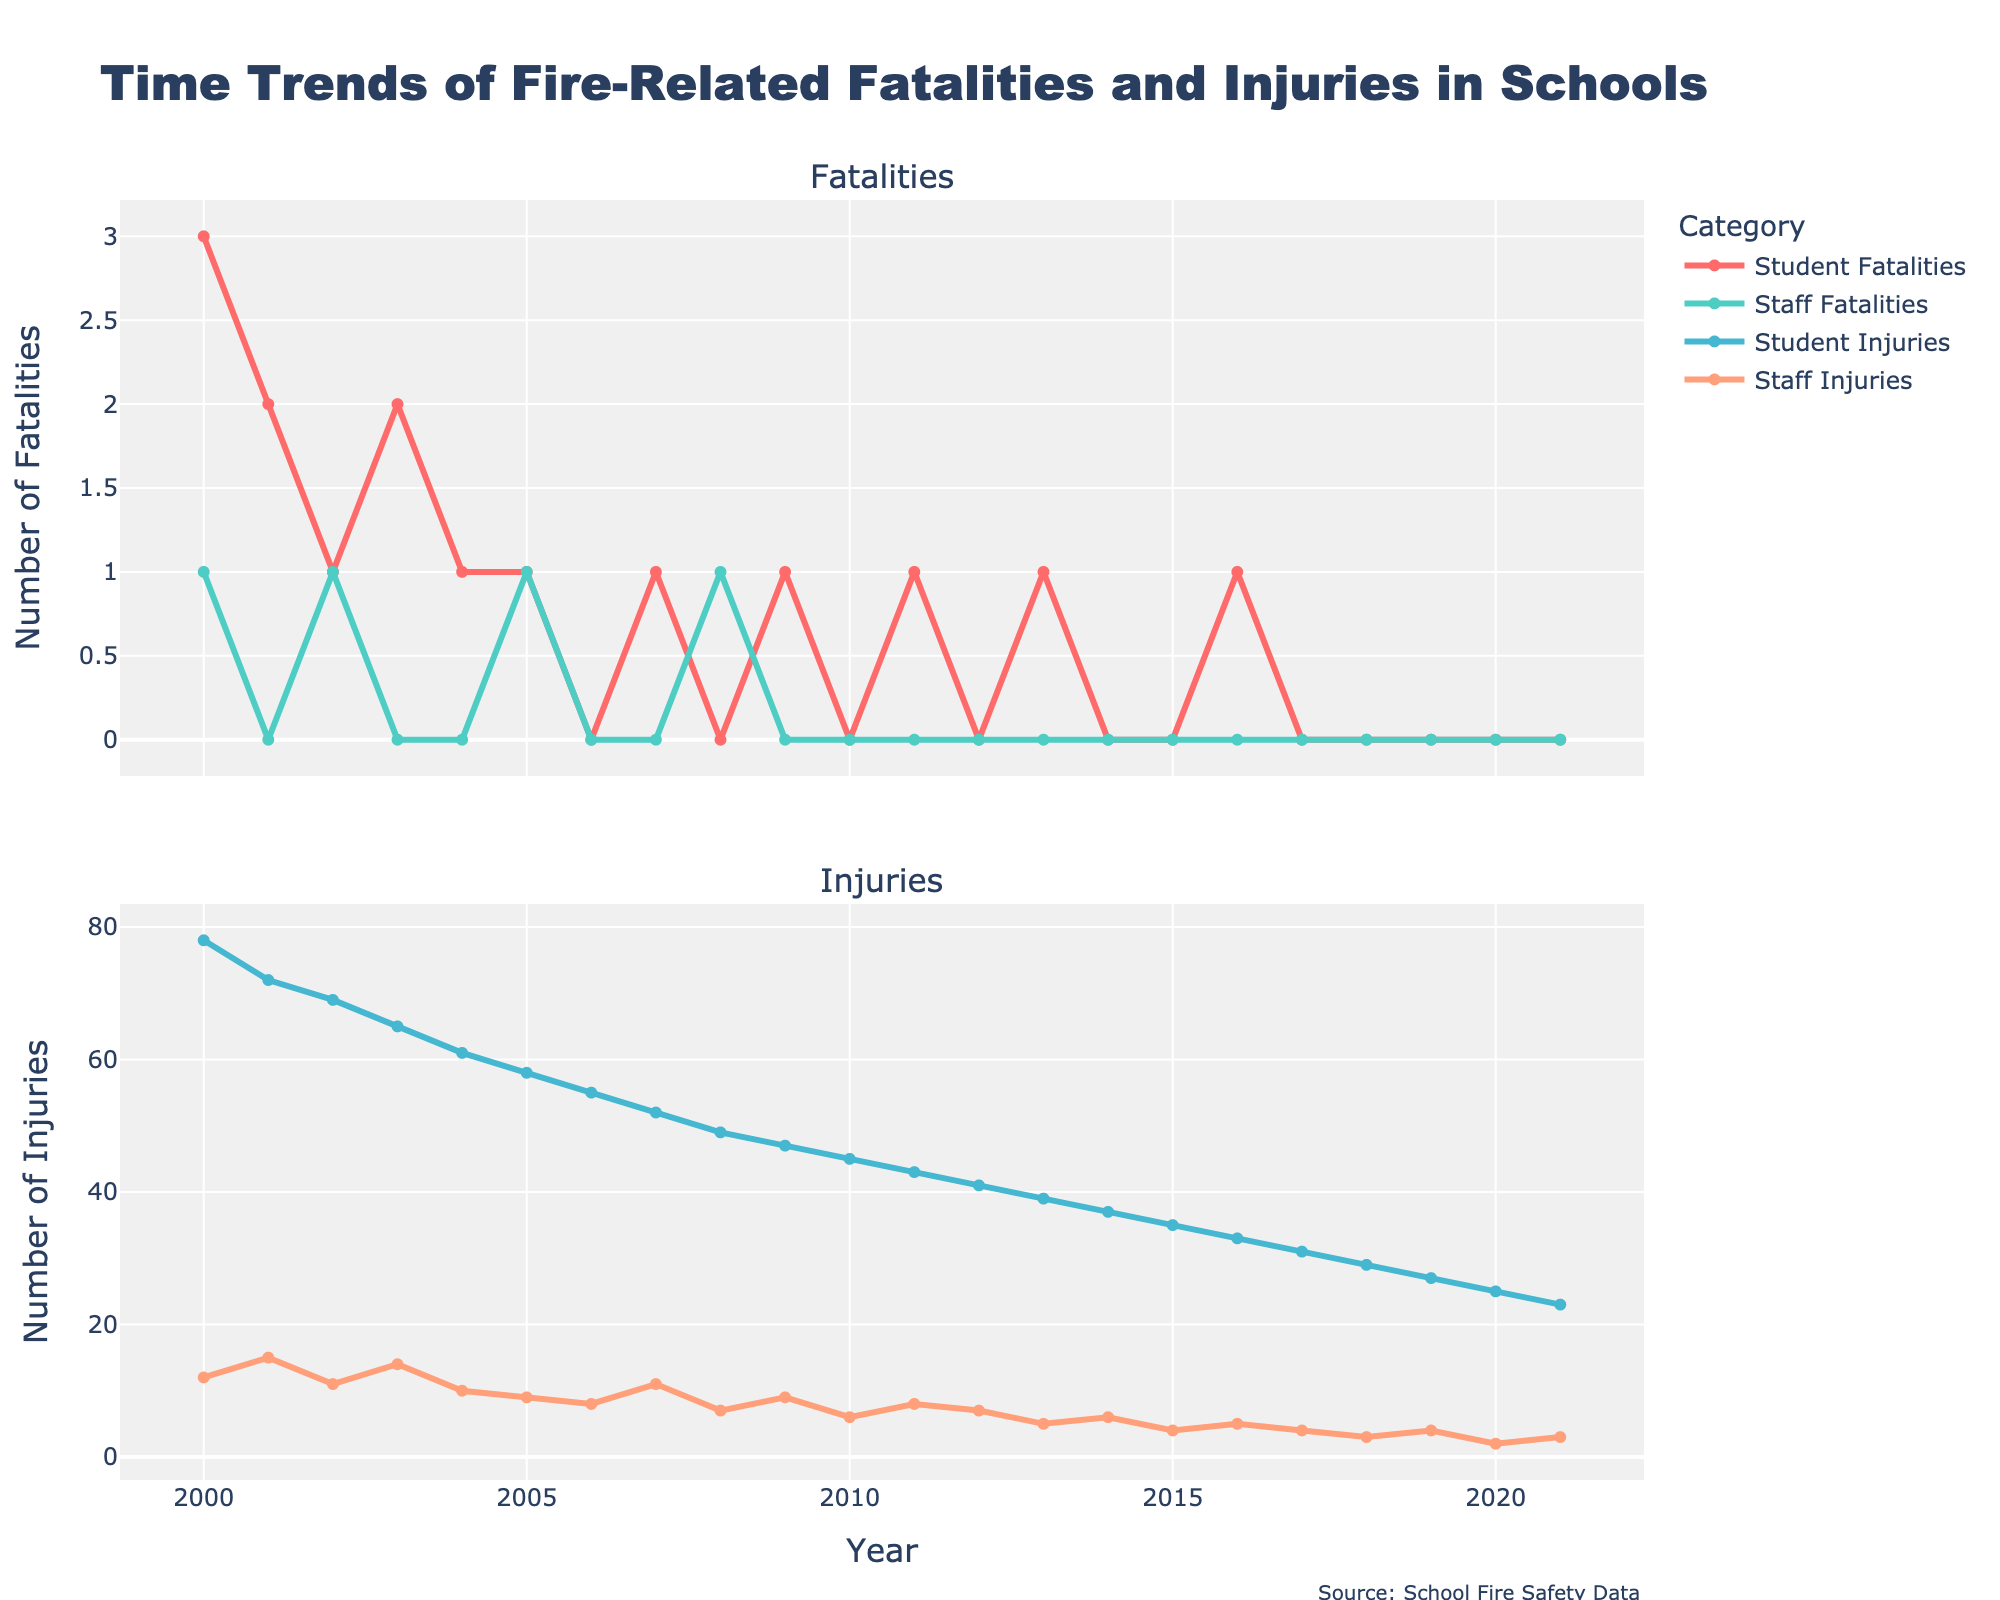How has the number of student fatalities changed from 2000 to 2021? To determine this, observe the line representing Student Fatalities from 2000 to 2021. Initially, in 2000, there were 3 student fatalities. By 2021, this number has decreased to 0. Verify the values across different years to confirm the overall decreasing trend.
Answer: Decreased Which category saw a decrease in fatalities, student or staff, by 2021 compared to 2000? Observe both the Student Fatalities and Staff Fatalities lines. In 2000, there were 3 student fatalities and 1 staff fatality. In 2021, there were 0 fatalities for both students and staff. Since both categories had fatalities in 2000 that became zero in 2021, both saw a decrease.
Answer: Both In which year did student injuries first drop below 50? Track the Student Injuries line across the years. Notice the value is first below 50 in the year 2008, where it reaches 49.
Answer: 2008 What is the difference between student and staff injuries in 2005? Compare Student Injuries and Staff Injuries values for 2005. Students had 58 injuries, while staff had 9 injuries, resulting in a difference of 58 - 9 = 49.
Answer: 49 In which year were staff fatalities highest? Identify the peak point on the Staff Fatalities line. In 2000 and 2002, staff fatalities were 1, the highest values observed.
Answer: 2000 and 2002 Was there any year where student fatalities were equal to staff fatalities? Check both the Student Fatalities and Staff Fatalities lines for overlapping values. In 2002 and 2008, both students and staff had 1 fatality each, showing equality.
Answer: 2002 and 2008 How many times did student injuries decrease consecutively from 2000 to 2021? Examine the Student Injuries line for consecutive decreases. The pattern shows a consistent year-on-year decrease from 2000 to 2021. To count: 2000-2001, 2001-2002, and so on, up to 2020-2021. This results in 21 consecutive decreases.
Answer: 21 What is the average number of student injuries for the years 2017 to 2021? Sum the Student Injuries values from 2017 (31), 2018 (29), 2019 (27), 2020 (25), and 2021 (23), which totals 135. Next, divide by the 5 years: 135 / 5 = 27.
Answer: 27 